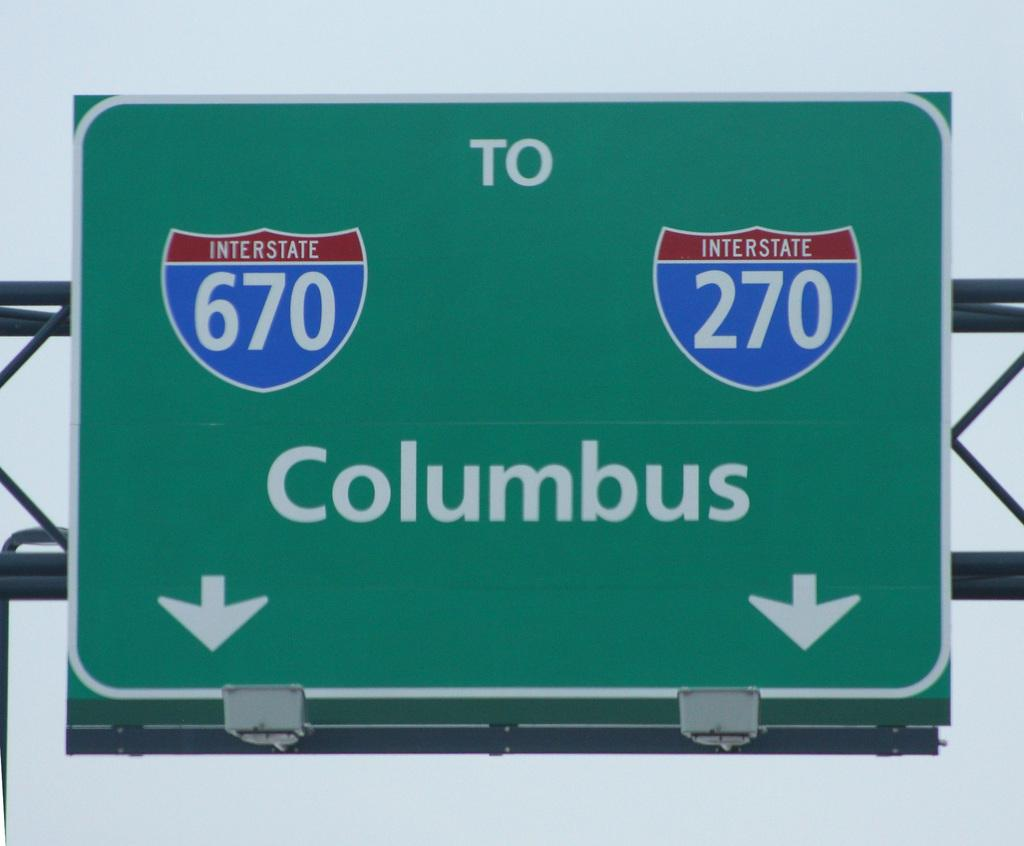<image>
Render a clear and concise summary of the photo. a Columbus sign with the number 670 on it 